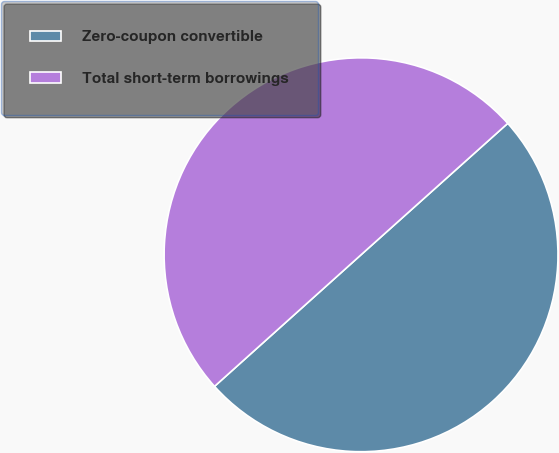Convert chart to OTSL. <chart><loc_0><loc_0><loc_500><loc_500><pie_chart><fcel>Zero-coupon convertible<fcel>Total short-term borrowings<nl><fcel>49.98%<fcel>50.02%<nl></chart> 